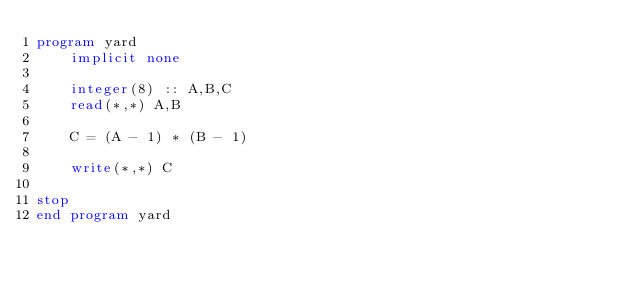Convert code to text. <code><loc_0><loc_0><loc_500><loc_500><_FORTRAN_>program yard
	implicit none
    
    integer(8) :: A,B,C
    read(*,*) A,B
    
    C = (A - 1) * (B - 1) 

	write(*,*) C

stop
end program yard</code> 